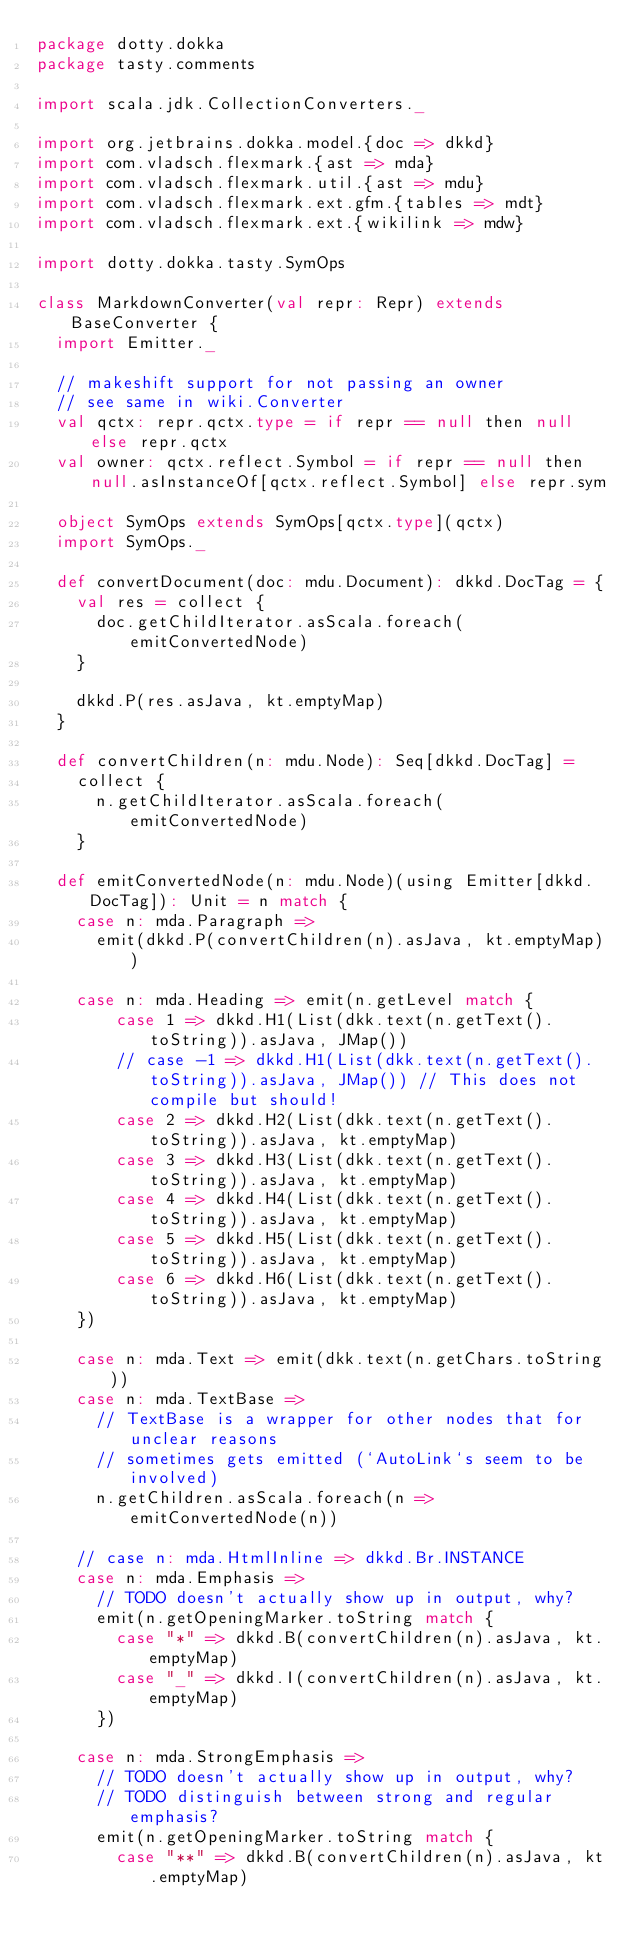<code> <loc_0><loc_0><loc_500><loc_500><_Scala_>package dotty.dokka
package tasty.comments

import scala.jdk.CollectionConverters._

import org.jetbrains.dokka.model.{doc => dkkd}
import com.vladsch.flexmark.{ast => mda}
import com.vladsch.flexmark.util.{ast => mdu}
import com.vladsch.flexmark.ext.gfm.{tables => mdt}
import com.vladsch.flexmark.ext.{wikilink => mdw}

import dotty.dokka.tasty.SymOps

class MarkdownConverter(val repr: Repr) extends BaseConverter {
  import Emitter._

  // makeshift support for not passing an owner
  // see same in wiki.Converter
  val qctx: repr.qctx.type = if repr == null then null else repr.qctx
  val owner: qctx.reflect.Symbol = if repr == null then null.asInstanceOf[qctx.reflect.Symbol] else repr.sym

  object SymOps extends SymOps[qctx.type](qctx)
  import SymOps._

  def convertDocument(doc: mdu.Document): dkkd.DocTag = {
    val res = collect {
      doc.getChildIterator.asScala.foreach(emitConvertedNode)
    }

    dkkd.P(res.asJava, kt.emptyMap)
  }

  def convertChildren(n: mdu.Node): Seq[dkkd.DocTag] =
    collect {
      n.getChildIterator.asScala.foreach(emitConvertedNode)
    }

  def emitConvertedNode(n: mdu.Node)(using Emitter[dkkd.DocTag]): Unit = n match {
    case n: mda.Paragraph =>
      emit(dkkd.P(convertChildren(n).asJava, kt.emptyMap))

    case n: mda.Heading => emit(n.getLevel match {
        case 1 => dkkd.H1(List(dkk.text(n.getText().toString)).asJava, JMap())
        // case -1 => dkkd.H1(List(dkk.text(n.getText().toString)).asJava, JMap()) // This does not compile but should!
        case 2 => dkkd.H2(List(dkk.text(n.getText().toString)).asJava, kt.emptyMap)
        case 3 => dkkd.H3(List(dkk.text(n.getText().toString)).asJava, kt.emptyMap)
        case 4 => dkkd.H4(List(dkk.text(n.getText().toString)).asJava, kt.emptyMap)
        case 5 => dkkd.H5(List(dkk.text(n.getText().toString)).asJava, kt.emptyMap)
        case 6 => dkkd.H6(List(dkk.text(n.getText().toString)).asJava, kt.emptyMap)
    })

    case n: mda.Text => emit(dkk.text(n.getChars.toString))
    case n: mda.TextBase =>
      // TextBase is a wrapper for other nodes that for unclear reasons
      // sometimes gets emitted (`AutoLink`s seem to be involved)
      n.getChildren.asScala.foreach(n => emitConvertedNode(n))

    // case n: mda.HtmlInline => dkkd.Br.INSTANCE
    case n: mda.Emphasis =>
      // TODO doesn't actually show up in output, why?
      emit(n.getOpeningMarker.toString match {
        case "*" => dkkd.B(convertChildren(n).asJava, kt.emptyMap)
        case "_" => dkkd.I(convertChildren(n).asJava, kt.emptyMap)
      })

    case n: mda.StrongEmphasis =>
      // TODO doesn't actually show up in output, why?
      // TODO distinguish between strong and regular emphasis?
      emit(n.getOpeningMarker.toString match {
        case "**" => dkkd.B(convertChildren(n).asJava, kt.emptyMap)</code> 